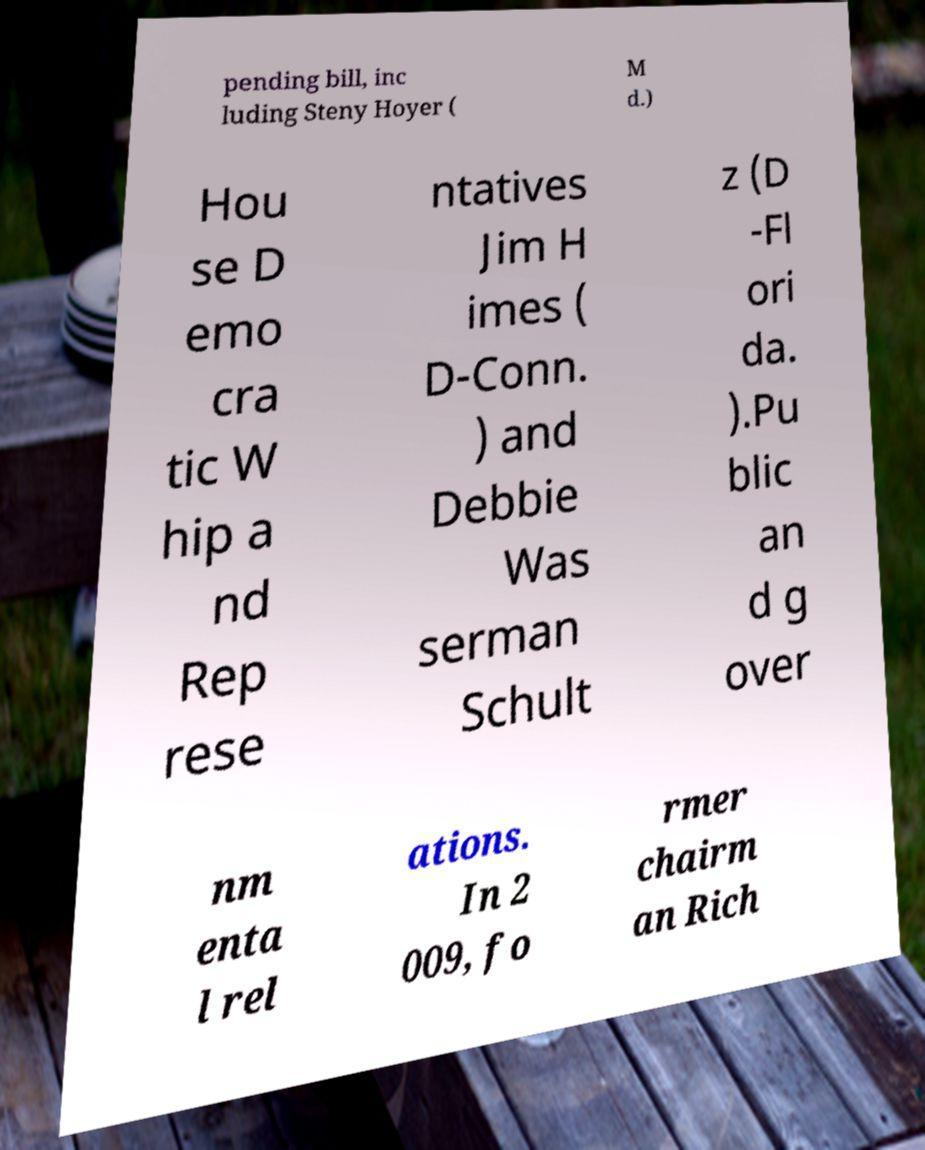What messages or text are displayed in this image? I need them in a readable, typed format. pending bill, inc luding Steny Hoyer ( M d.) Hou se D emo cra tic W hip a nd Rep rese ntatives Jim H imes ( D-Conn. ) and Debbie Was serman Schult z (D -Fl ori da. ).Pu blic an d g over nm enta l rel ations. In 2 009, fo rmer chairm an Rich 